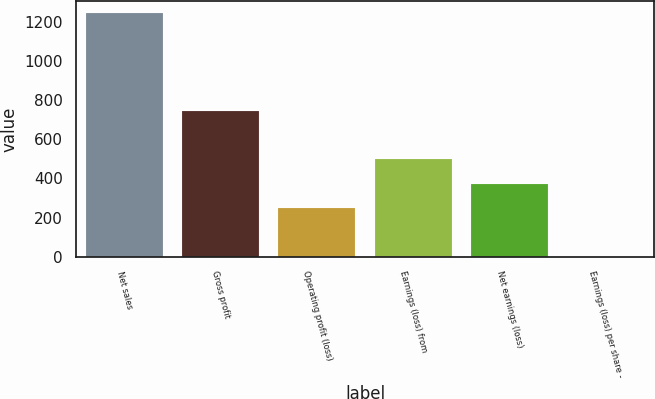Convert chart to OTSL. <chart><loc_0><loc_0><loc_500><loc_500><bar_chart><fcel>Net sales<fcel>Gross profit<fcel>Operating profit (loss)<fcel>Earnings (loss) from<fcel>Net earnings (loss)<fcel>Earnings (loss) per share -<nl><fcel>1244<fcel>746.64<fcel>249.32<fcel>497.98<fcel>373.65<fcel>0.66<nl></chart> 